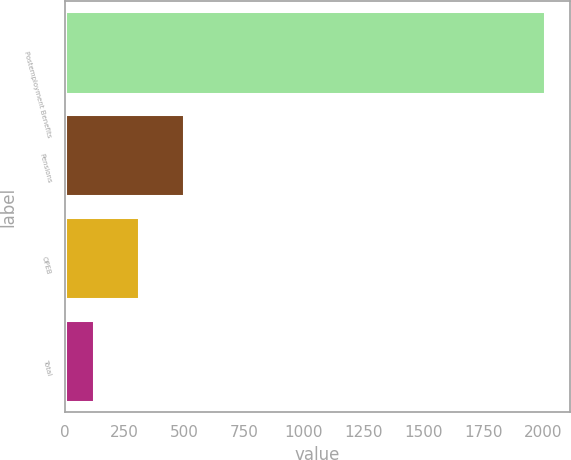Convert chart. <chart><loc_0><loc_0><loc_500><loc_500><bar_chart><fcel>Postemployment Benefits<fcel>Pensions<fcel>OPEB<fcel>Total<nl><fcel>2010<fcel>498.8<fcel>309.9<fcel>121<nl></chart> 